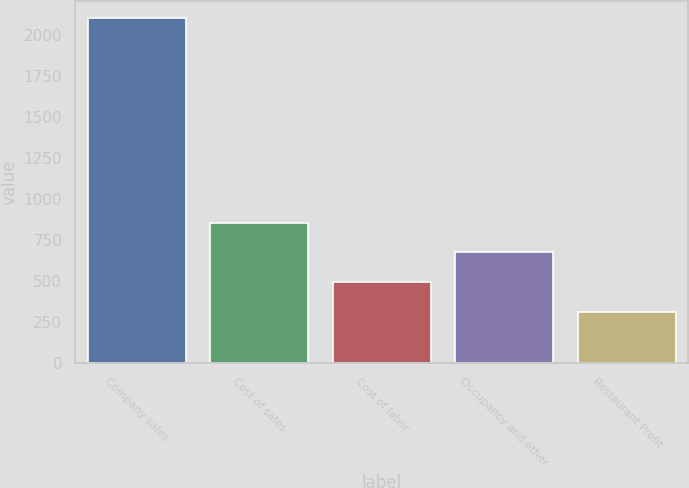Convert chart. <chart><loc_0><loc_0><loc_500><loc_500><bar_chart><fcel>Company sales<fcel>Cost of sales<fcel>Cost of labor<fcel>Occupancy and other<fcel>Restaurant Profit<nl><fcel>2106<fcel>855.8<fcel>497<fcel>676.4<fcel>312<nl></chart> 